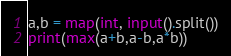Convert code to text. <code><loc_0><loc_0><loc_500><loc_500><_Python_>a,b = map(int, input().split())
print(max(a+b,a-b,a*b))</code> 